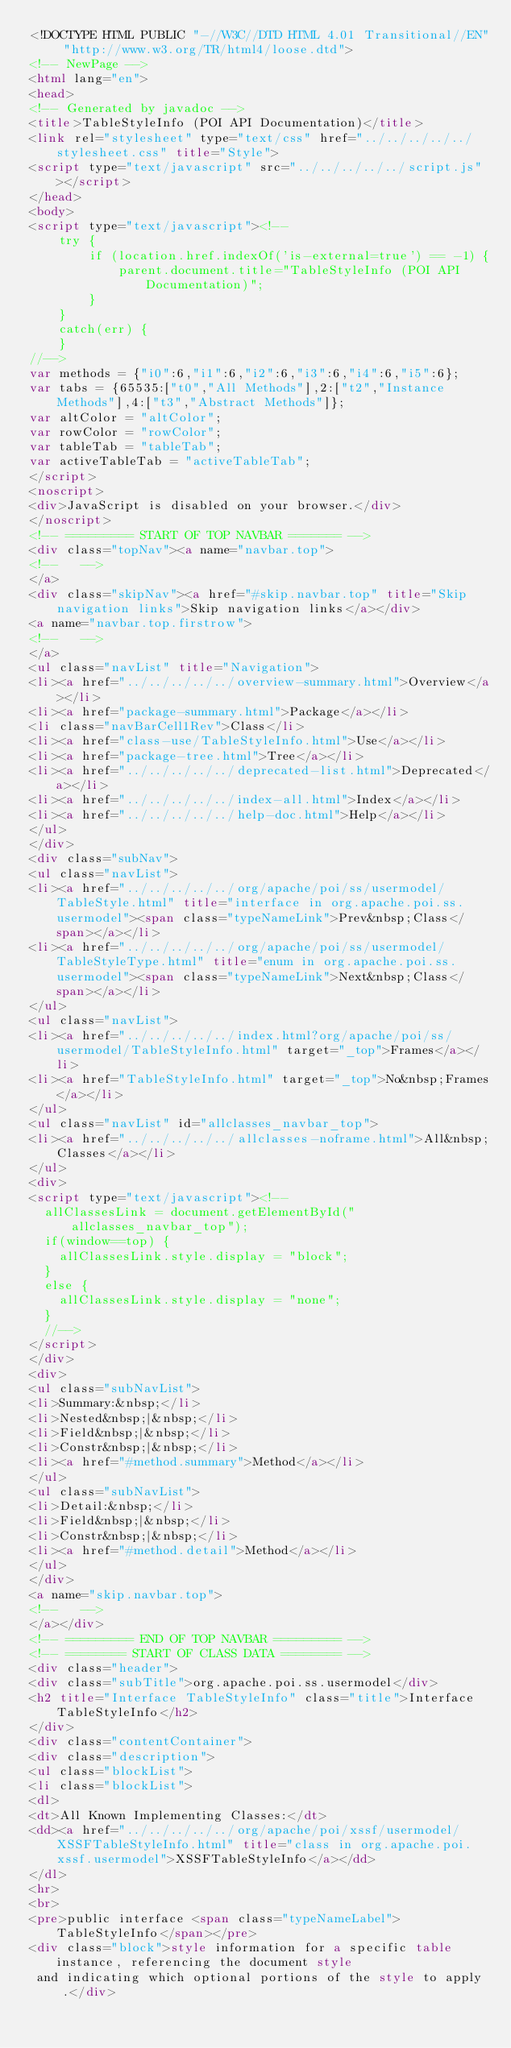Convert code to text. <code><loc_0><loc_0><loc_500><loc_500><_HTML_><!DOCTYPE HTML PUBLIC "-//W3C//DTD HTML 4.01 Transitional//EN" "http://www.w3.org/TR/html4/loose.dtd">
<!-- NewPage -->
<html lang="en">
<head>
<!-- Generated by javadoc -->
<title>TableStyleInfo (POI API Documentation)</title>
<link rel="stylesheet" type="text/css" href="../../../../../stylesheet.css" title="Style">
<script type="text/javascript" src="../../../../../script.js"></script>
</head>
<body>
<script type="text/javascript"><!--
    try {
        if (location.href.indexOf('is-external=true') == -1) {
            parent.document.title="TableStyleInfo (POI API Documentation)";
        }
    }
    catch(err) {
    }
//-->
var methods = {"i0":6,"i1":6,"i2":6,"i3":6,"i4":6,"i5":6};
var tabs = {65535:["t0","All Methods"],2:["t2","Instance Methods"],4:["t3","Abstract Methods"]};
var altColor = "altColor";
var rowColor = "rowColor";
var tableTab = "tableTab";
var activeTableTab = "activeTableTab";
</script>
<noscript>
<div>JavaScript is disabled on your browser.</div>
</noscript>
<!-- ========= START OF TOP NAVBAR ======= -->
<div class="topNav"><a name="navbar.top">
<!--   -->
</a>
<div class="skipNav"><a href="#skip.navbar.top" title="Skip navigation links">Skip navigation links</a></div>
<a name="navbar.top.firstrow">
<!--   -->
</a>
<ul class="navList" title="Navigation">
<li><a href="../../../../../overview-summary.html">Overview</a></li>
<li><a href="package-summary.html">Package</a></li>
<li class="navBarCell1Rev">Class</li>
<li><a href="class-use/TableStyleInfo.html">Use</a></li>
<li><a href="package-tree.html">Tree</a></li>
<li><a href="../../../../../deprecated-list.html">Deprecated</a></li>
<li><a href="../../../../../index-all.html">Index</a></li>
<li><a href="../../../../../help-doc.html">Help</a></li>
</ul>
</div>
<div class="subNav">
<ul class="navList">
<li><a href="../../../../../org/apache/poi/ss/usermodel/TableStyle.html" title="interface in org.apache.poi.ss.usermodel"><span class="typeNameLink">Prev&nbsp;Class</span></a></li>
<li><a href="../../../../../org/apache/poi/ss/usermodel/TableStyleType.html" title="enum in org.apache.poi.ss.usermodel"><span class="typeNameLink">Next&nbsp;Class</span></a></li>
</ul>
<ul class="navList">
<li><a href="../../../../../index.html?org/apache/poi/ss/usermodel/TableStyleInfo.html" target="_top">Frames</a></li>
<li><a href="TableStyleInfo.html" target="_top">No&nbsp;Frames</a></li>
</ul>
<ul class="navList" id="allclasses_navbar_top">
<li><a href="../../../../../allclasses-noframe.html">All&nbsp;Classes</a></li>
</ul>
<div>
<script type="text/javascript"><!--
  allClassesLink = document.getElementById("allclasses_navbar_top");
  if(window==top) {
    allClassesLink.style.display = "block";
  }
  else {
    allClassesLink.style.display = "none";
  }
  //-->
</script>
</div>
<div>
<ul class="subNavList">
<li>Summary:&nbsp;</li>
<li>Nested&nbsp;|&nbsp;</li>
<li>Field&nbsp;|&nbsp;</li>
<li>Constr&nbsp;|&nbsp;</li>
<li><a href="#method.summary">Method</a></li>
</ul>
<ul class="subNavList">
<li>Detail:&nbsp;</li>
<li>Field&nbsp;|&nbsp;</li>
<li>Constr&nbsp;|&nbsp;</li>
<li><a href="#method.detail">Method</a></li>
</ul>
</div>
<a name="skip.navbar.top">
<!--   -->
</a></div>
<!-- ========= END OF TOP NAVBAR ========= -->
<!-- ======== START OF CLASS DATA ======== -->
<div class="header">
<div class="subTitle">org.apache.poi.ss.usermodel</div>
<h2 title="Interface TableStyleInfo" class="title">Interface TableStyleInfo</h2>
</div>
<div class="contentContainer">
<div class="description">
<ul class="blockList">
<li class="blockList">
<dl>
<dt>All Known Implementing Classes:</dt>
<dd><a href="../../../../../org/apache/poi/xssf/usermodel/XSSFTableStyleInfo.html" title="class in org.apache.poi.xssf.usermodel">XSSFTableStyleInfo</a></dd>
</dl>
<hr>
<br>
<pre>public interface <span class="typeNameLabel">TableStyleInfo</span></pre>
<div class="block">style information for a specific table instance, referencing the document style
 and indicating which optional portions of the style to apply.</div></code> 